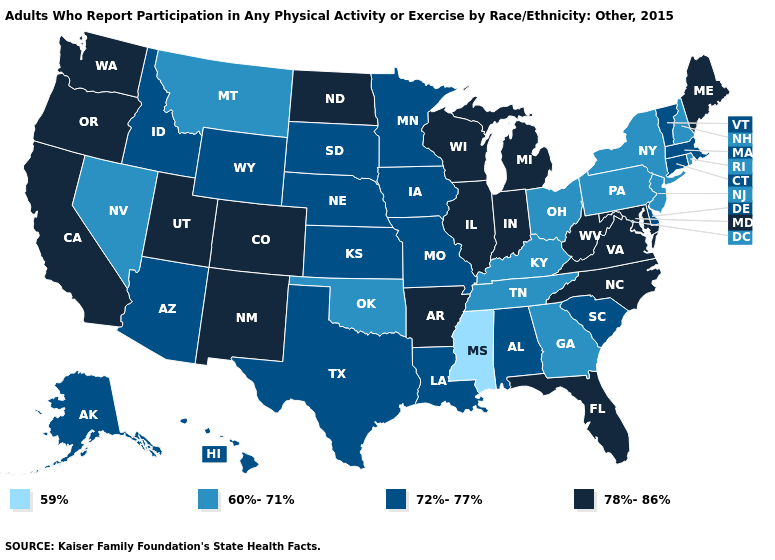Name the states that have a value in the range 59%?
Answer briefly. Mississippi. What is the value of Georgia?
Concise answer only. 60%-71%. Name the states that have a value in the range 59%?
Answer briefly. Mississippi. Does Missouri have the highest value in the USA?
Be succinct. No. What is the highest value in states that border New Jersey?
Quick response, please. 72%-77%. Name the states that have a value in the range 78%-86%?
Keep it brief. Arkansas, California, Colorado, Florida, Illinois, Indiana, Maine, Maryland, Michigan, New Mexico, North Carolina, North Dakota, Oregon, Utah, Virginia, Washington, West Virginia, Wisconsin. What is the lowest value in the West?
Concise answer only. 60%-71%. What is the lowest value in states that border Maryland?
Give a very brief answer. 60%-71%. What is the value of Kansas?
Short answer required. 72%-77%. Does Montana have the highest value in the West?
Be succinct. No. Name the states that have a value in the range 59%?
Short answer required. Mississippi. Does Maryland have the lowest value in the South?
Concise answer only. No. Does Georgia have the same value as Texas?
Keep it brief. No. Name the states that have a value in the range 59%?
Concise answer only. Mississippi. What is the value of Connecticut?
Concise answer only. 72%-77%. 